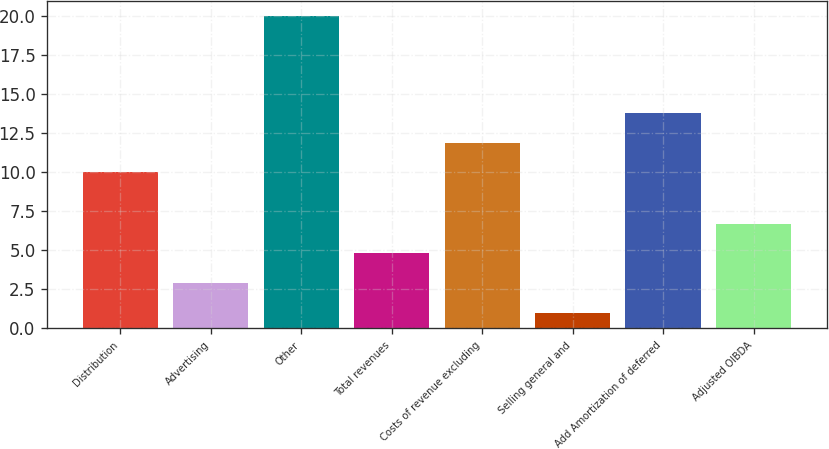Convert chart. <chart><loc_0><loc_0><loc_500><loc_500><bar_chart><fcel>Distribution<fcel>Advertising<fcel>Other<fcel>Total revenues<fcel>Costs of revenue excluding<fcel>Selling general and<fcel>Add Amortization of deferred<fcel>Adjusted OIBDA<nl><fcel>10<fcel>2.9<fcel>20<fcel>4.8<fcel>11.9<fcel>1<fcel>13.8<fcel>6.7<nl></chart> 